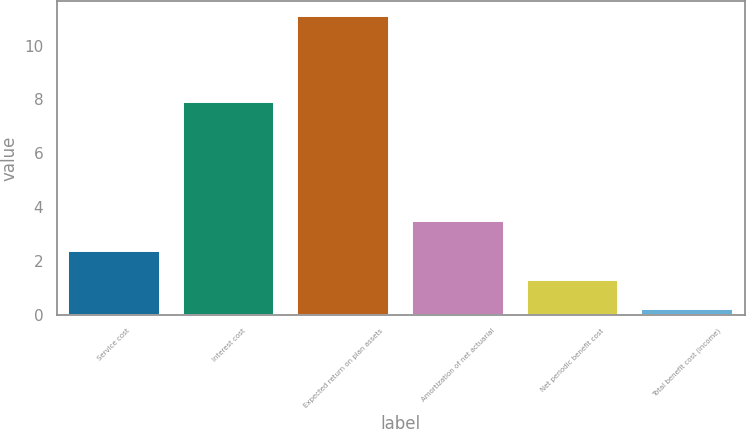Convert chart. <chart><loc_0><loc_0><loc_500><loc_500><bar_chart><fcel>Service cost<fcel>Interest cost<fcel>Expected return on plan assets<fcel>Amortization of net actuarial<fcel>Net periodic benefit cost<fcel>Total benefit cost (income)<nl><fcel>2.38<fcel>7.9<fcel>11.1<fcel>3.47<fcel>1.29<fcel>0.2<nl></chart> 